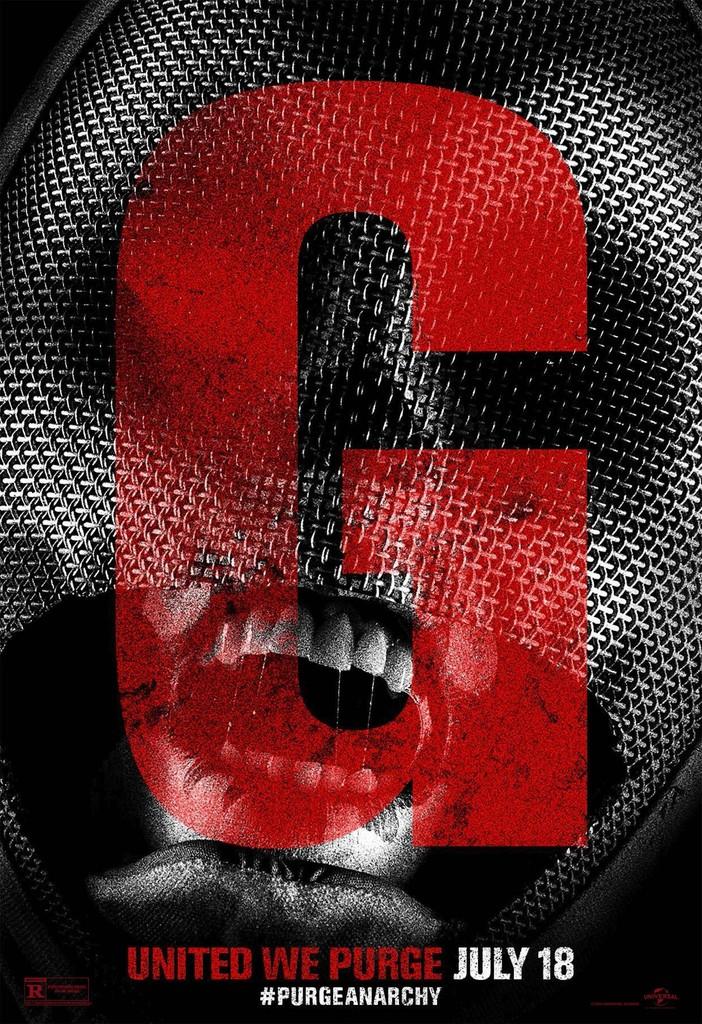What is the large red letter?
Ensure brevity in your answer.  G. What is the month on this poster?
Ensure brevity in your answer.  July. 